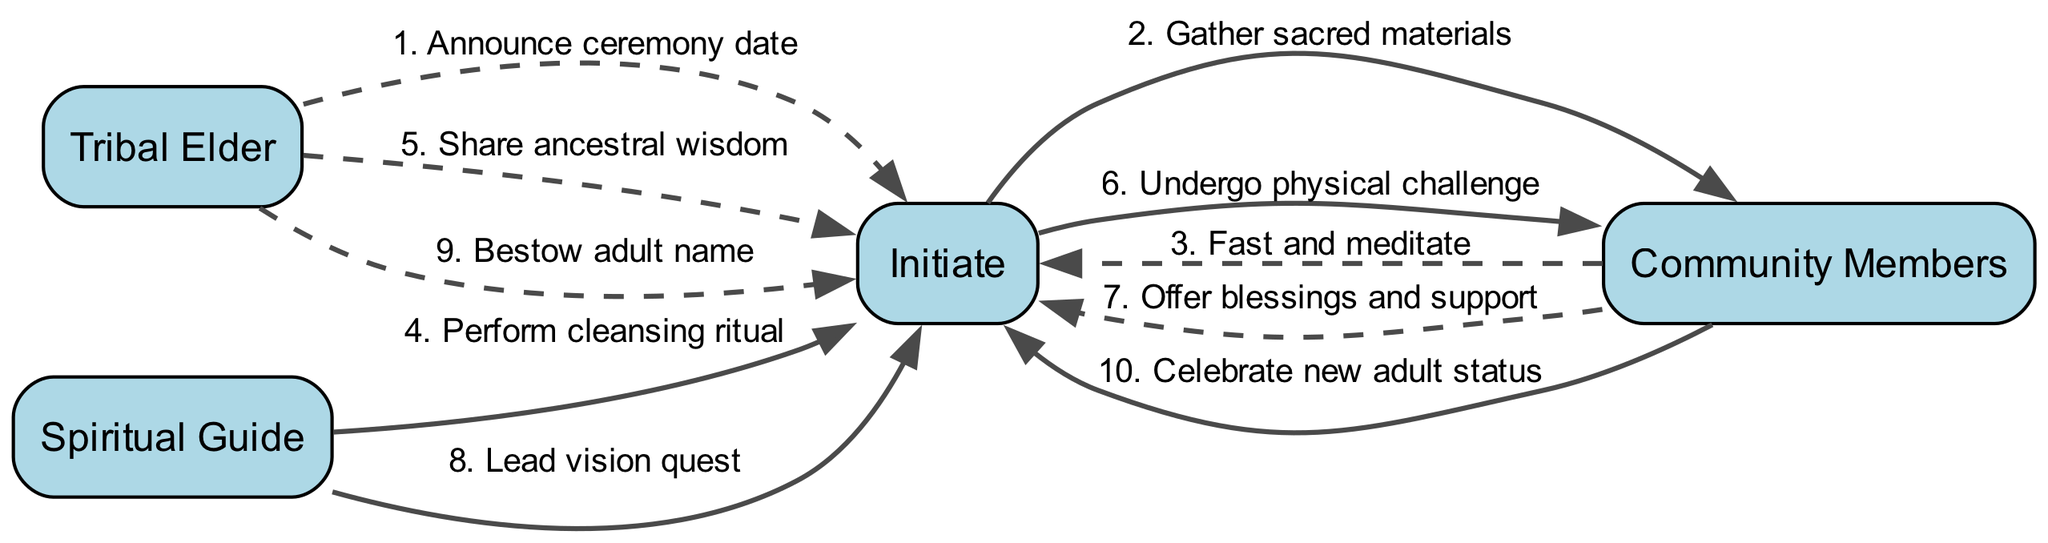What is the first action in the sequence? The first action is indicated by the first edge in the sequence diagram, where the Tribal Elder announces the ceremony date to the Initiate.
Answer: Announce ceremony date How many participants are involved in the ceremony? The sequence diagram lists four participants: Tribal Elder, Initiate, Community Members, and Spiritual Guide.
Answer: Four Which participant performs the cleansing ritual? By following the edge that links the Spiritual Guide to the Initiate, the cleansing ritual is performed by the Spiritual Guide.
Answer: Spiritual Guide What message does the Tribal Elder send after the cleansing ritual? The Tribal Elder sends the message to share ancestral wisdom after the Spiritual Guide performs the cleansing ritual, as shown in the sequence flow.
Answer: Share ancestral wisdom What is the last action in the sequence? The last action is indicated by the final edge, where Community Members celebrate the new adult status of the Initiate.
Answer: Celebrate new adult status How many edges are there in total? Counting all the edges connecting participants in the sequence yields a total of ten events.
Answer: Ten Identify the action that requires the Initiate to gather materials. The Initiate is instructed to gather sacred materials in the second action according to the sequence flow.
Answer: Gather sacred materials Which participant leads the vision quest? The edge from the Spiritual Guide to the Initiate indicates that the Spiritual Guide leads the vision quest.
Answer: Spiritual Guide What kind of message is exchanged between Community Members and the Initiate during the physical challenge? The message exchanged is categorized as an offer of blessings and support from the Community Members to the Initiate during this stage of the ceremony.
Answer: Offer blessings and support Which two nodes show a solid line and represent alternating actions? The third and fifth actions in the sequence diagram represent the messages exchanged with solid lines: "Fast and meditate" and "Undergo physical challenge."
Answer: Fast and meditate, Undergo physical challenge 